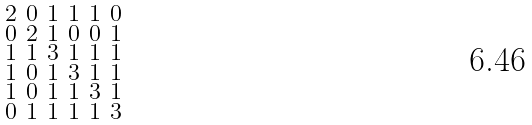Convert formula to latex. <formula><loc_0><loc_0><loc_500><loc_500>\begin{smallmatrix} 2 & 0 & 1 & 1 & 1 & 0 \\ 0 & 2 & 1 & 0 & 0 & 1 \\ 1 & 1 & 3 & 1 & 1 & 1 \\ 1 & 0 & 1 & 3 & 1 & 1 \\ 1 & 0 & 1 & 1 & 3 & 1 \\ 0 & 1 & 1 & 1 & 1 & 3 \end{smallmatrix}</formula> 